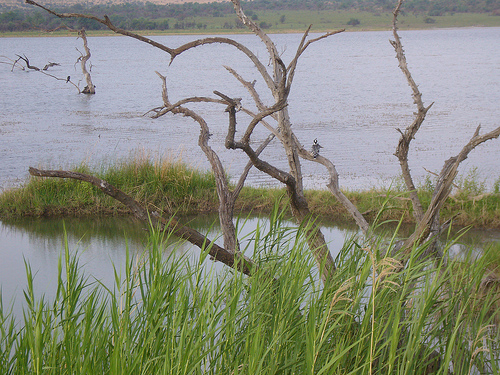<image>
Can you confirm if the water is under the tree? Yes. The water is positioned underneath the tree, with the tree above it in the vertical space. 